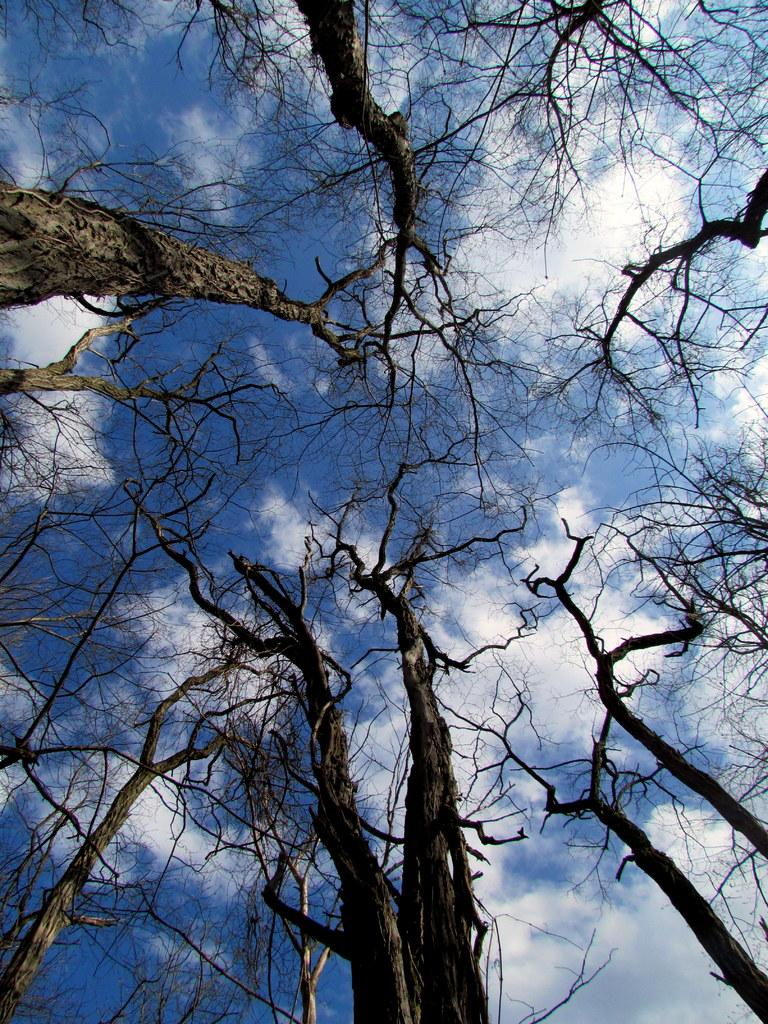What type of trees are in the image? There are dry trees in the image. What is the color of the sky in the image? The sky is blue and white in color. What type of lipstick is the tree wearing in the image? There are no trees wearing lipstick in the image, as trees do not have the ability to wear makeup. 